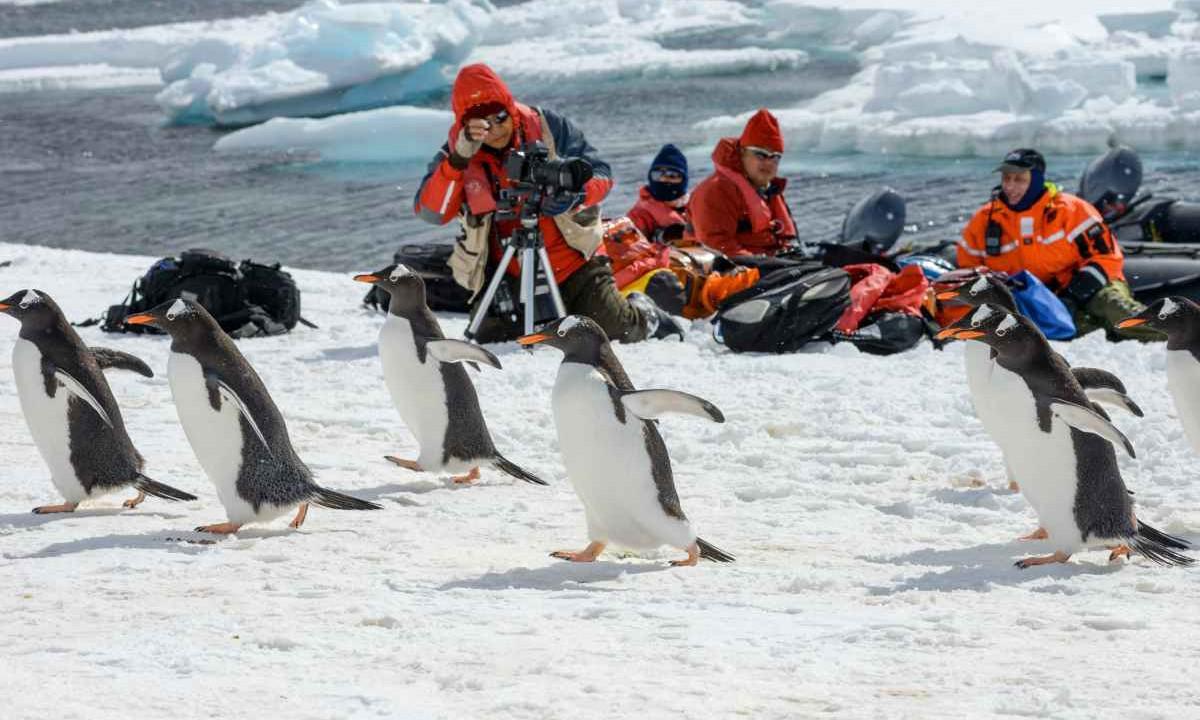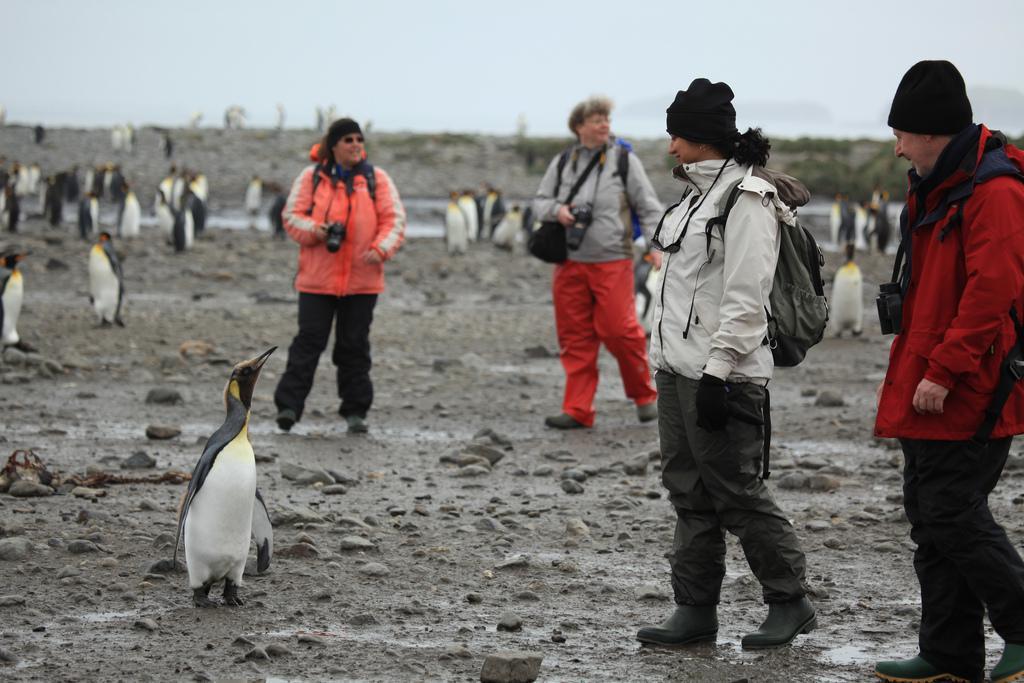The first image is the image on the left, the second image is the image on the right. Considering the images on both sides, is "One of the images shows at least one brown fluffy penguin near the black and white penguins." valid? Answer yes or no. No. The first image is the image on the left, the second image is the image on the right. Analyze the images presented: Is the assertion "Penguins are the only living creatures in the images." valid? Answer yes or no. No. 